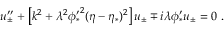<formula> <loc_0><loc_0><loc_500><loc_500>u _ { \pm } ^ { \prime \prime } + \left [ k ^ { 2 } + \lambda ^ { 2 } { \phi _ { * } ^ { \prime } } ^ { 2 } ( \eta - \eta _ { * } ) ^ { 2 } \right ] u _ { \pm } \mp i \lambda \phi _ { * } ^ { \prime } u _ { \pm } = 0 \ .</formula> 